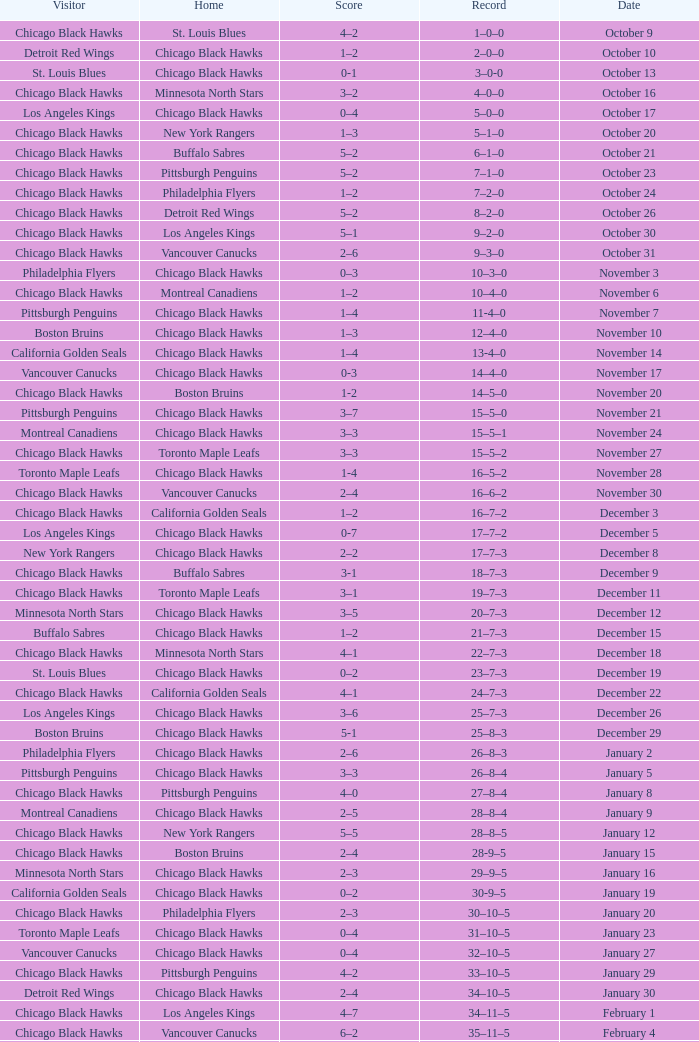What is the Record of the February 26 date? 39–16–7. 